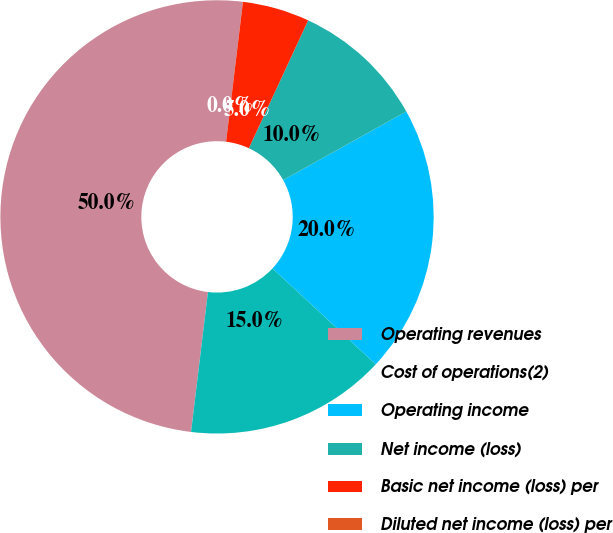Convert chart. <chart><loc_0><loc_0><loc_500><loc_500><pie_chart><fcel>Operating revenues<fcel>Cost of operations(2)<fcel>Operating income<fcel>Net income (loss)<fcel>Basic net income (loss) per<fcel>Diluted net income (loss) per<nl><fcel>50.0%<fcel>15.0%<fcel>20.0%<fcel>10.0%<fcel>5.0%<fcel>0.0%<nl></chart> 